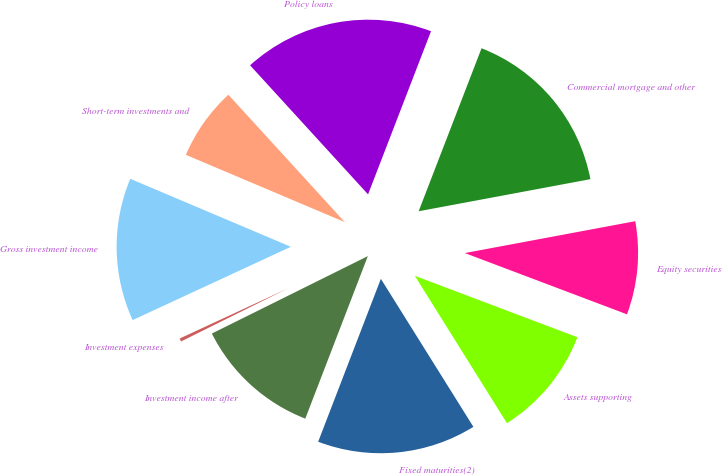Convert chart to OTSL. <chart><loc_0><loc_0><loc_500><loc_500><pie_chart><fcel>Fixed maturities(2)<fcel>Assets supporting<fcel>Equity securities<fcel>Commercial mortgage and other<fcel>Policy loans<fcel>Short-term investments and<fcel>Gross investment income<fcel>Investment expenses<fcel>Investment income after<nl><fcel>14.74%<fcel>10.36%<fcel>8.69%<fcel>16.2%<fcel>17.65%<fcel>6.84%<fcel>13.28%<fcel>0.43%<fcel>11.82%<nl></chart> 